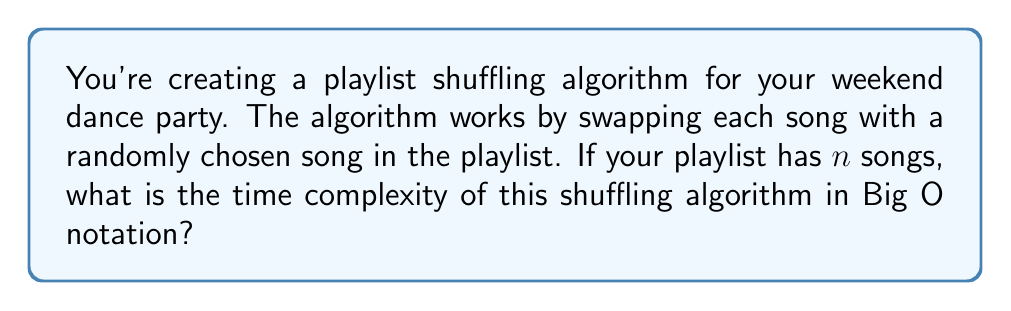Help me with this question. Let's break down the algorithm and analyze its time complexity:

1. The algorithm needs to go through each song in the playlist once. This means we have a loop that runs $n$ times, where $n$ is the number of songs.

2. For each iteration of this loop:
   a. We select the current song (constant time operation, $O(1)$)
   b. We generate a random index (also constant time, $O(1)$)
   c. We swap the current song with the song at the random index (again, constant time, $O(1)$)

3. The total number of operations for each iteration of the loop is the sum of these constant time operations, which is still constant time: $O(1) + O(1) + O(1) = O(1)$

4. Since we perform these constant time operations for each of the $n$ songs, we multiply the time complexity of the loop body by the number of iterations:

   $$O(n) * O(1) = O(n)$$

5. There are no other significant operations outside this main loop that would affect the overall time complexity.

Therefore, the time complexity of this playlist shuffling algorithm is linear, or $O(n)$, where $n$ is the number of songs in the playlist.
Answer: $O(n)$ 